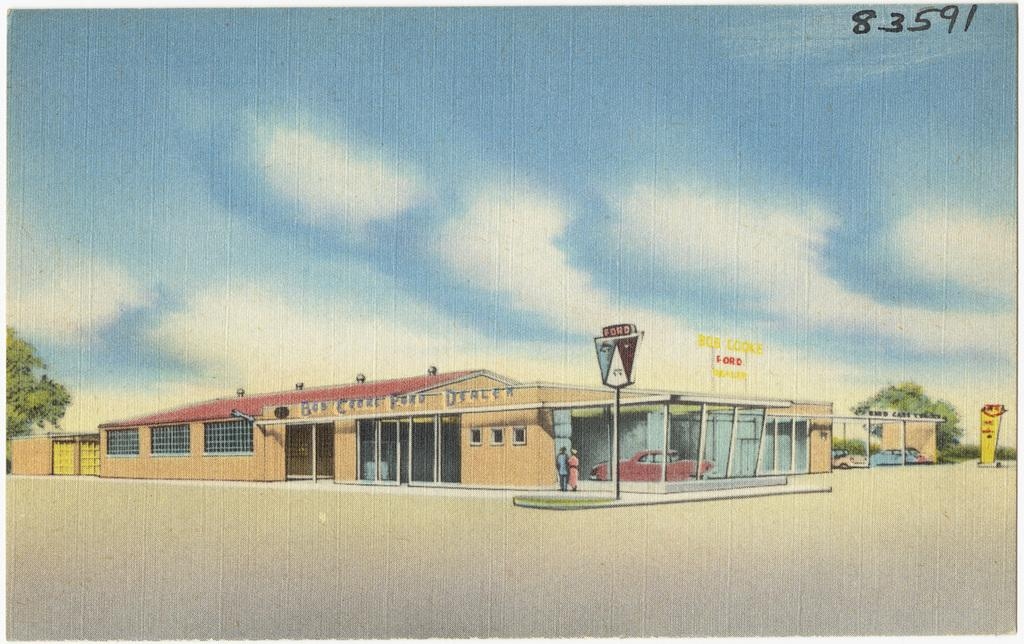Provide a one-sentence caption for the provided image. A Ford dealership is shown with the number 83591 in the corner. 